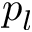<formula> <loc_0><loc_0><loc_500><loc_500>p _ { l }</formula> 